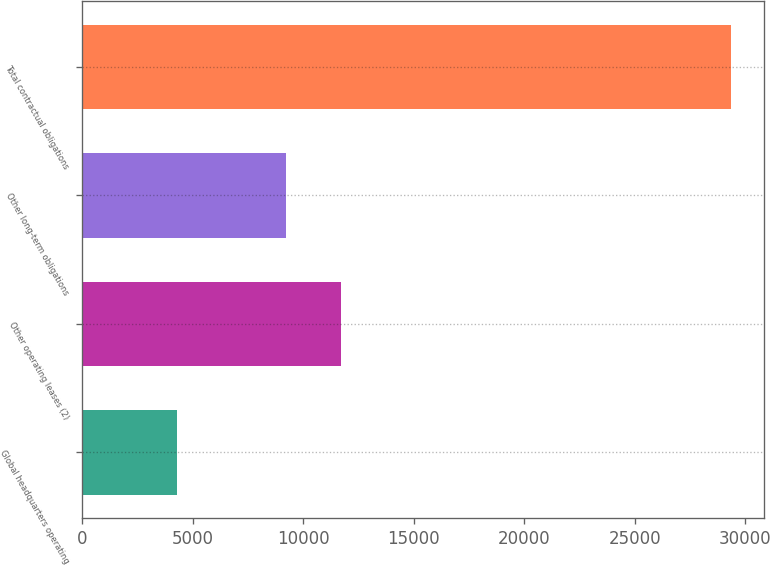Convert chart. <chart><loc_0><loc_0><loc_500><loc_500><bar_chart><fcel>Global headquarters operating<fcel>Other operating leases (2)<fcel>Other long-term obligations<fcel>Total contractual obligations<nl><fcel>4278<fcel>11713.1<fcel>9206<fcel>29349<nl></chart> 